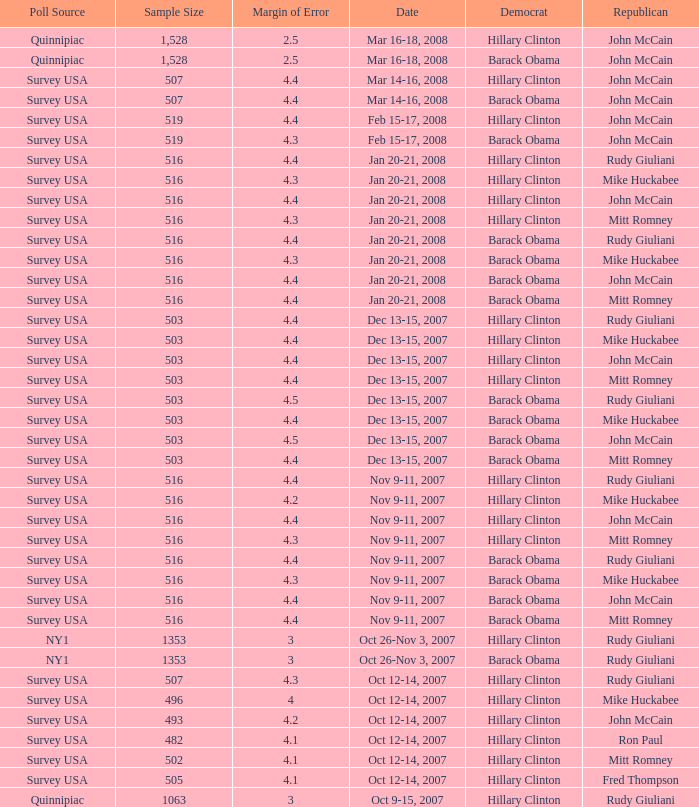What was the date of the poll with a sample size of 496 where Republican Mike Huckabee was chosen? Oct 12-14, 2007. 